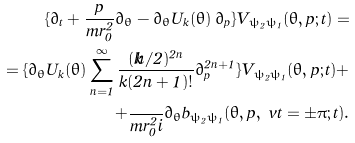Convert formula to latex. <formula><loc_0><loc_0><loc_500><loc_500>\{ \partial _ { t } + \frac { p } { m r _ { 0 } ^ { 2 } } \partial _ { \theta } - \partial _ { \theta } U _ { k } ( \theta ) \, \partial _ { p } \} V _ { \psi _ { 2 } \psi _ { 1 } } ( \theta , p ; t ) = \\ = \{ \partial _ { \theta } U _ { k } ( \theta ) \sum _ { n = 1 } ^ { \infty } \frac { ( k \hbar { / } 2 ) ^ { 2 n } } { k ( 2 n + 1 ) ! } \partial _ { p } ^ { 2 n + 1 } \} V _ { \psi _ { 2 } \psi _ { 1 } } ( \theta , p ; t ) + \\ + \frac { } { m r _ { 0 } ^ { 2 } i } \partial _ { \theta } b _ { \psi _ { 2 } \psi _ { 1 } } ( \theta , p , \ v t = \pm \pi ; t ) .</formula> 